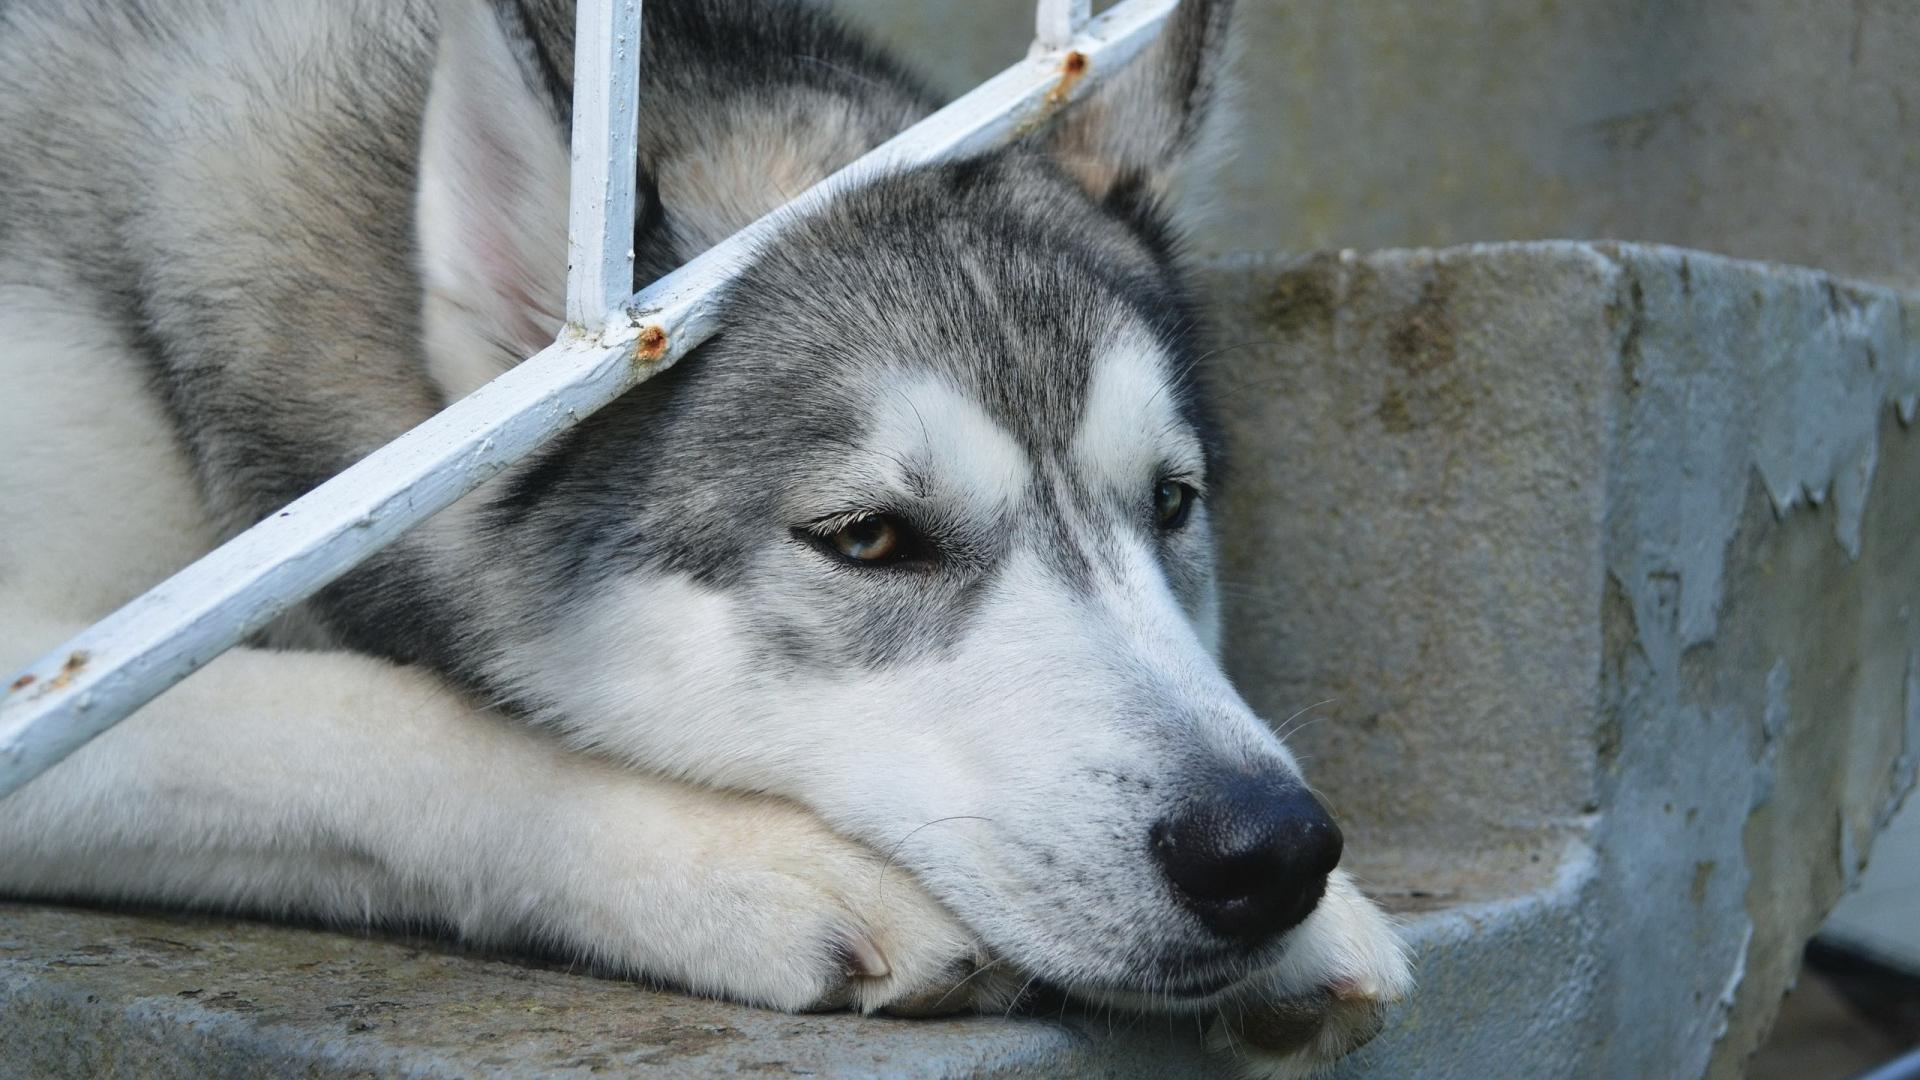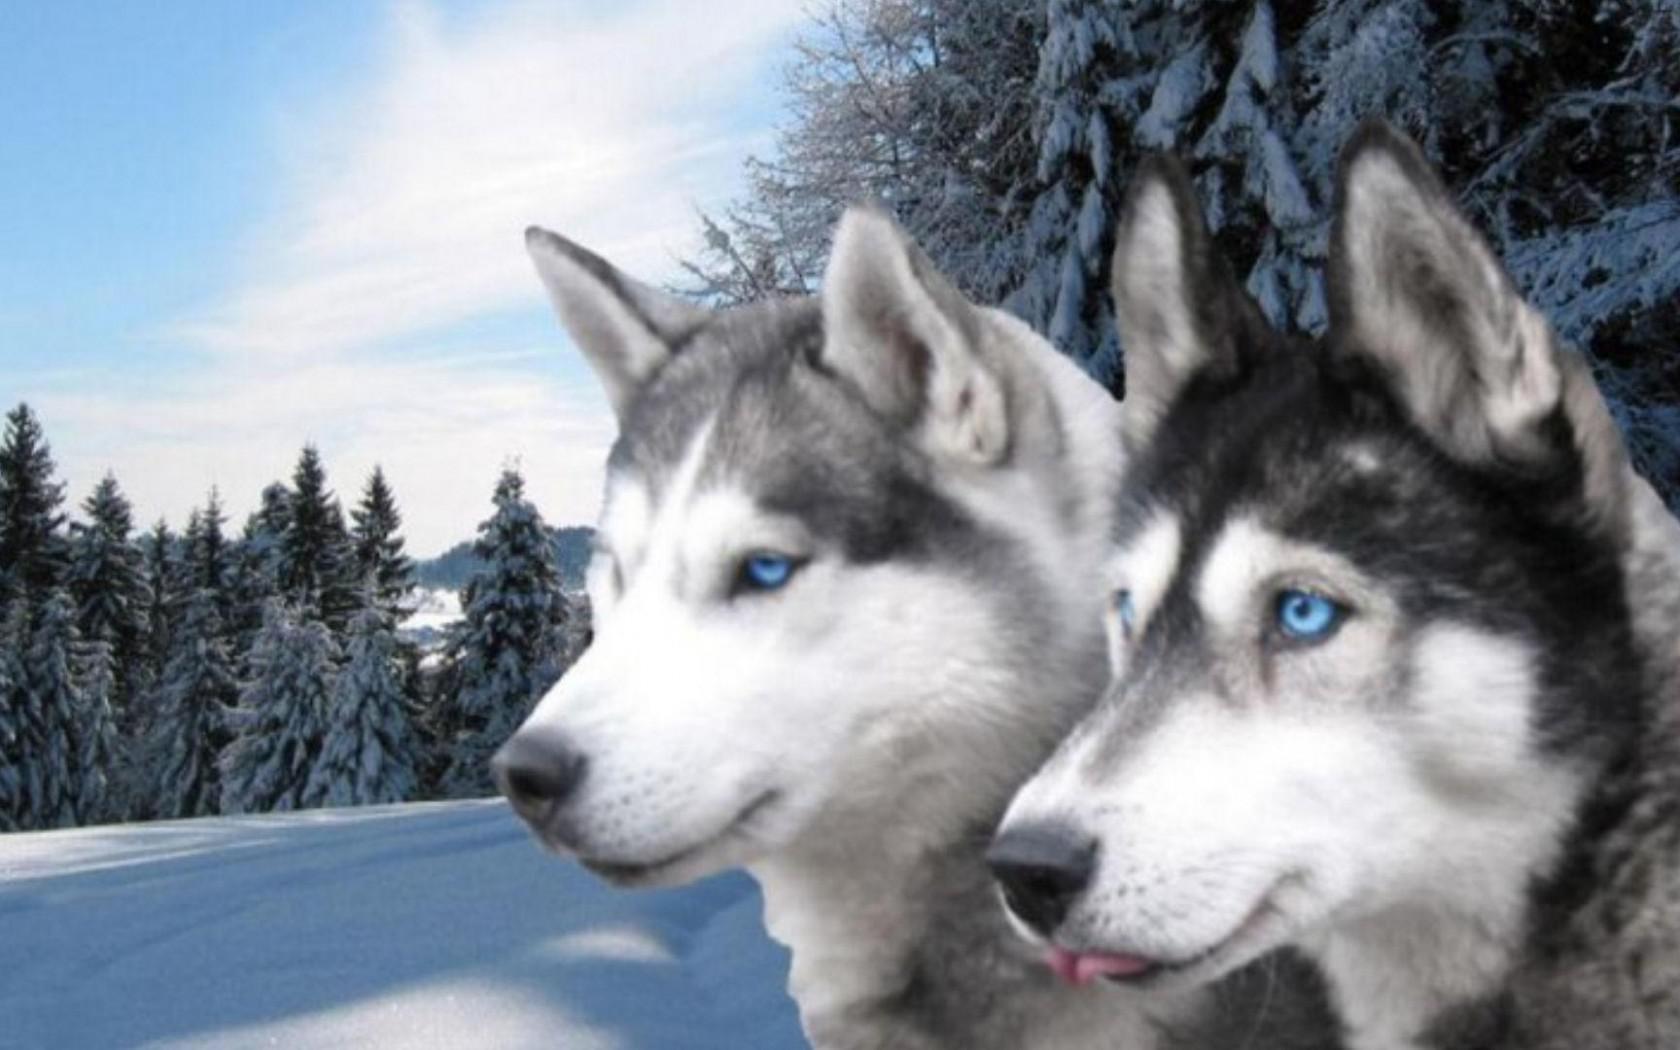The first image is the image on the left, the second image is the image on the right. Given the left and right images, does the statement "The right image contains exactly two dogs." hold true? Answer yes or no. Yes. The first image is the image on the left, the second image is the image on the right. Evaluate the accuracy of this statement regarding the images: "The right image shows two husky dogs of similar age and size, posed with their heads side-by-side, showing similar expressions.". Is it true? Answer yes or no. Yes. 